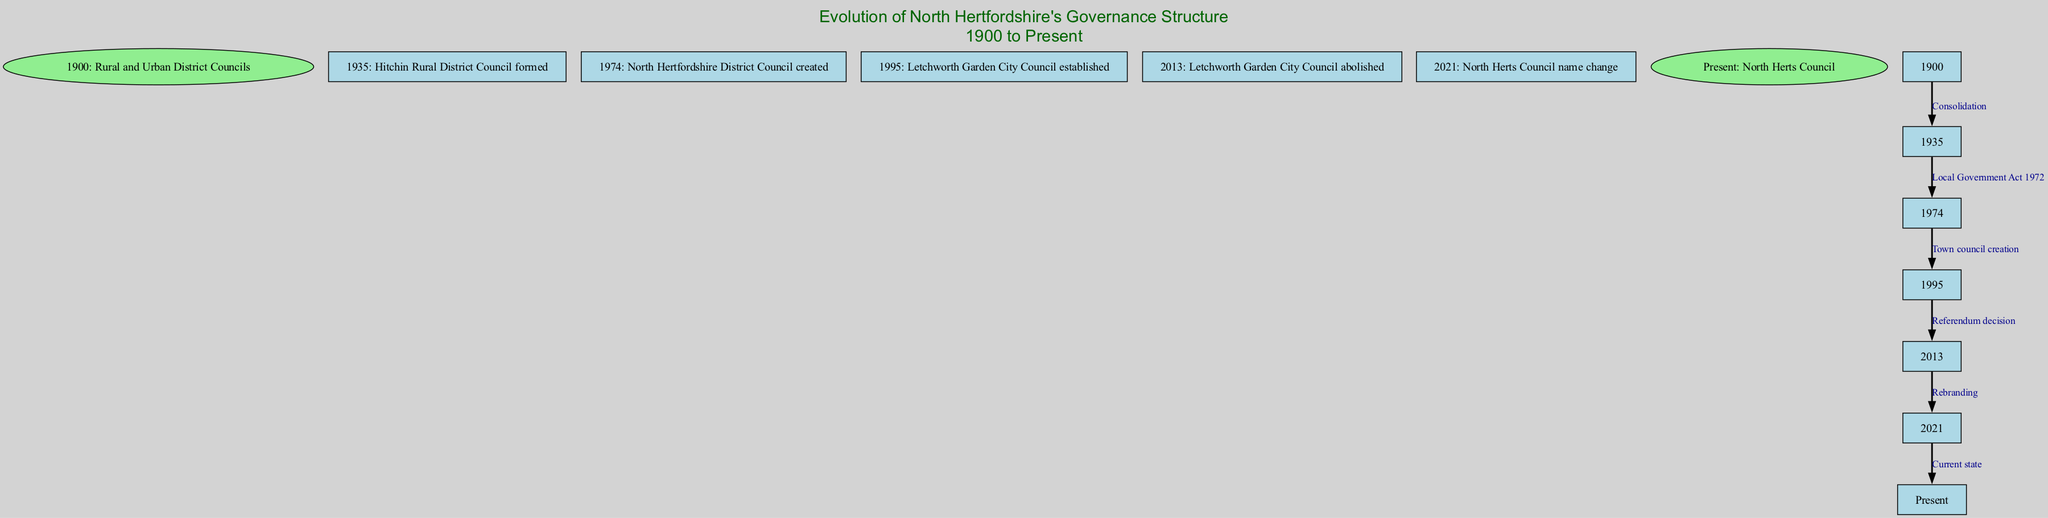What is the starting point of the governance evolution in North Hertfordshire? The diagram begins with the node labeled "1900: Rural and Urban District Councils," which represents the initial governance structure. Therefore, the starting point is identified clearly in the diagram.
Answer: 1900: Rural and Urban District Councils How many nodes are present in the diagram? The nodes include the starting point, the series of developments, and the end point—counting all distinct labeled points gives a total of six nodes.
Answer: 6 What is the label for the edge connecting "1935: Hitchin Rural District Council formed" to "1974: North Hertfordshire District Council created"? The edge connecting these two nodes is labeled "Local Government Act 1972," which signifies the legislative act responsible for this transition in governance.
Answer: Local Government Act 1972 What happened to the "Letchworth Garden City Council" in 2013? The diagram shows that "Letchworth Garden City Council" was abolished in 2013, indicating a significant change in local governance.
Answer: Abolished What was the event that caused the establishment of the "Letchworth Garden City Council"? The establishment of the "Letchworth Garden City Council" was a result of "Town council creation" as indicated by the edge leading to that node, highlighting the context of this governance structure's inception.
Answer: Town council creation What transition occurs between 2013 and 2021 in governance structure? The diagram indicates a "Rebranding" transition between these years, which signifies a change in the name of North Hertfordshire's governing body, from the abolished council to the name used today.
Answer: Rebranding What action took place in 1995 regarding local governance in North Hertfordshire? The diagram reveals that "Letchworth Garden City Council" was established in 1995, marking a new phase in local governance which followed earlier district council formations.
Answer: Established How many edges connect the nodes in the diagram? The diagram outlines five edges that connect all the nodes, detailing the transitions and important legislation or actions leading through the governance evolution.
Answer: 5 